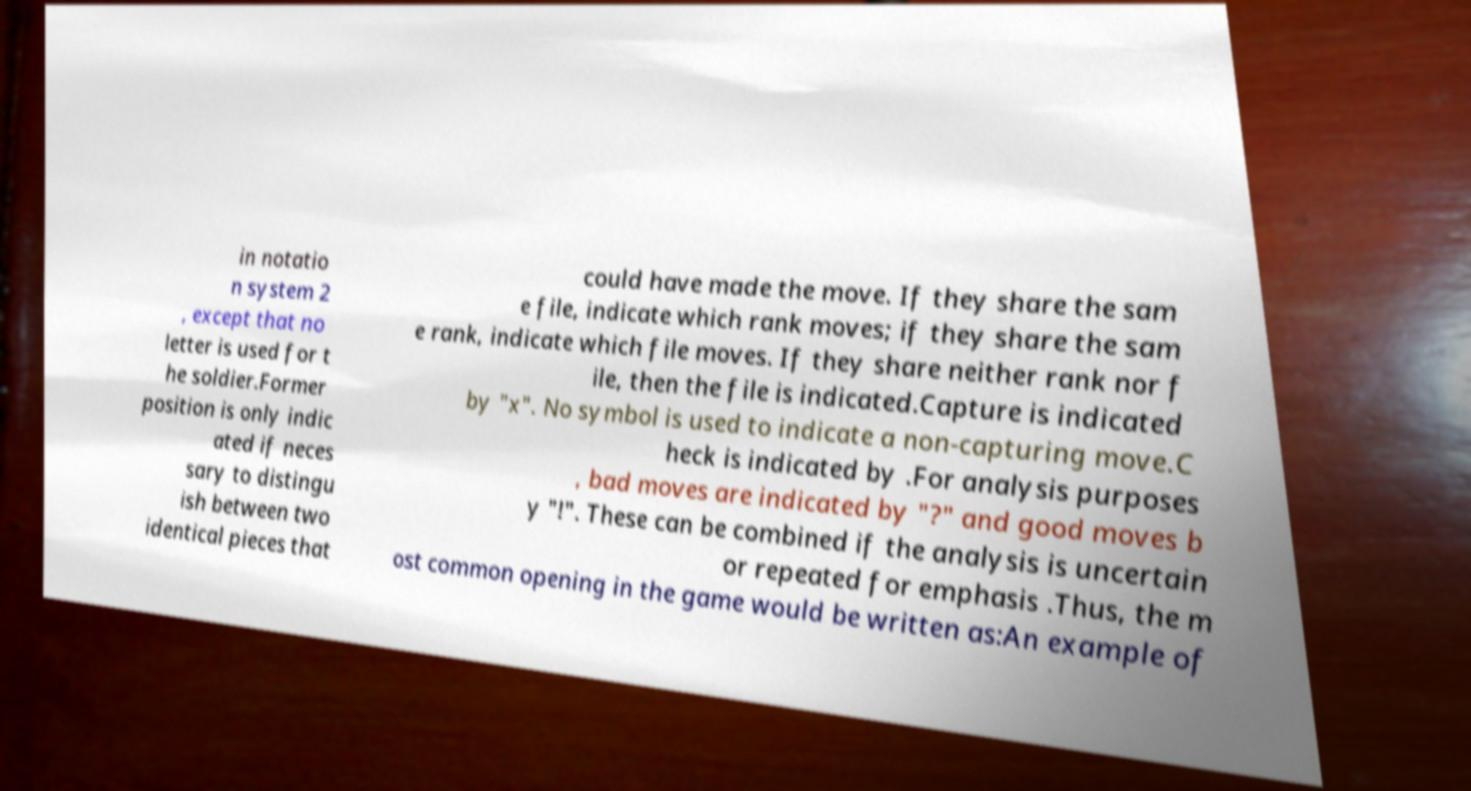For documentation purposes, I need the text within this image transcribed. Could you provide that? in notatio n system 2 , except that no letter is used for t he soldier.Former position is only indic ated if neces sary to distingu ish between two identical pieces that could have made the move. If they share the sam e file, indicate which rank moves; if they share the sam e rank, indicate which file moves. If they share neither rank nor f ile, then the file is indicated.Capture is indicated by "x". No symbol is used to indicate a non-capturing move.C heck is indicated by .For analysis purposes , bad moves are indicated by "?" and good moves b y "!". These can be combined if the analysis is uncertain or repeated for emphasis .Thus, the m ost common opening in the game would be written as:An example of 